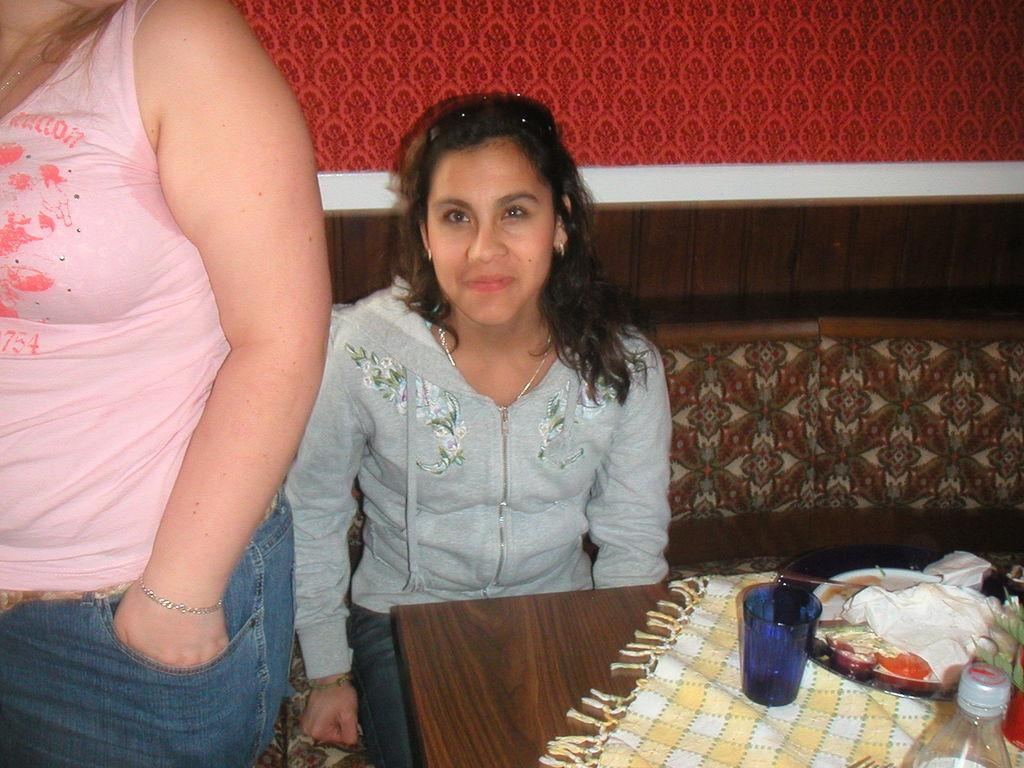How many people are in the image? There are two persons in the image. What are the positions of the two people in the image? One person is standing, and the other person is sitting. What can be seen on the table in the image? There are objects placed on a table in the image. What type of leather material is used for the print on the wall in the image? There is no print or leather material visible in the image. 